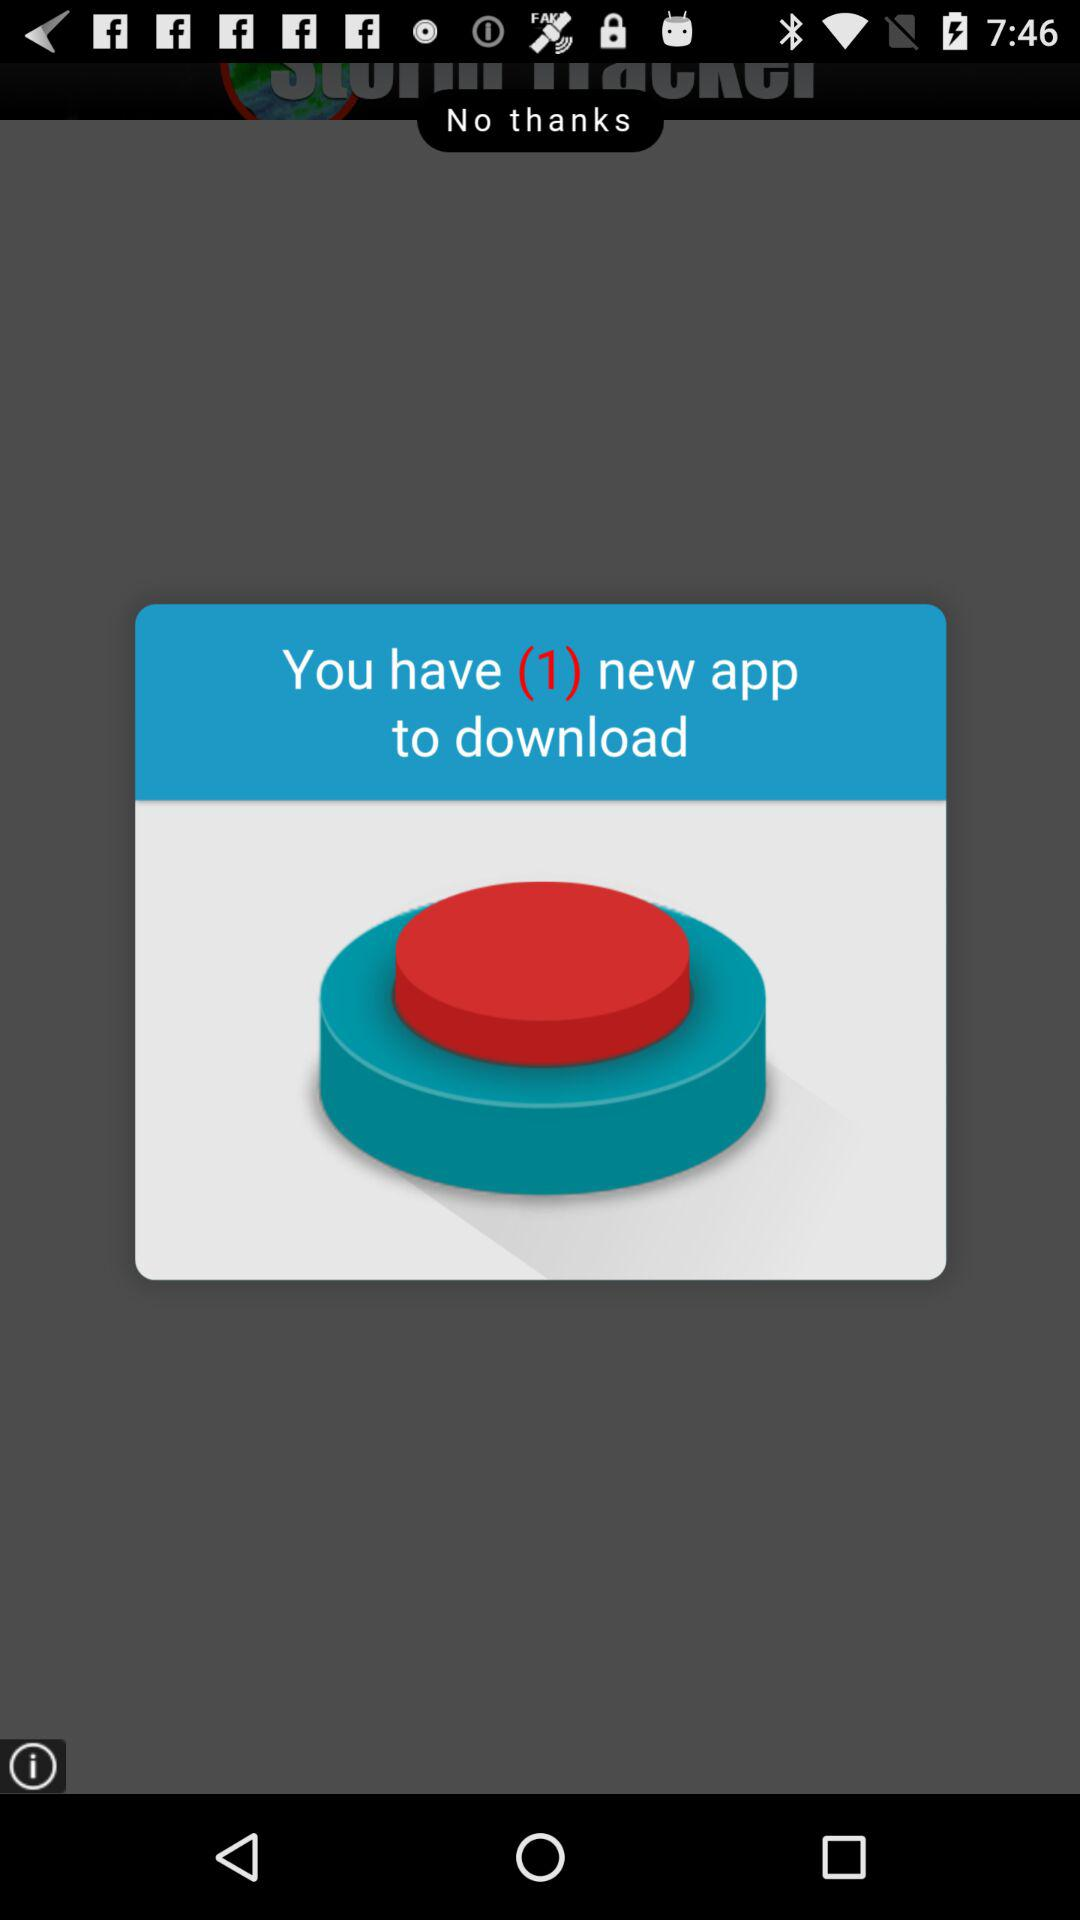How many applications are there to download? There is one application to download. 